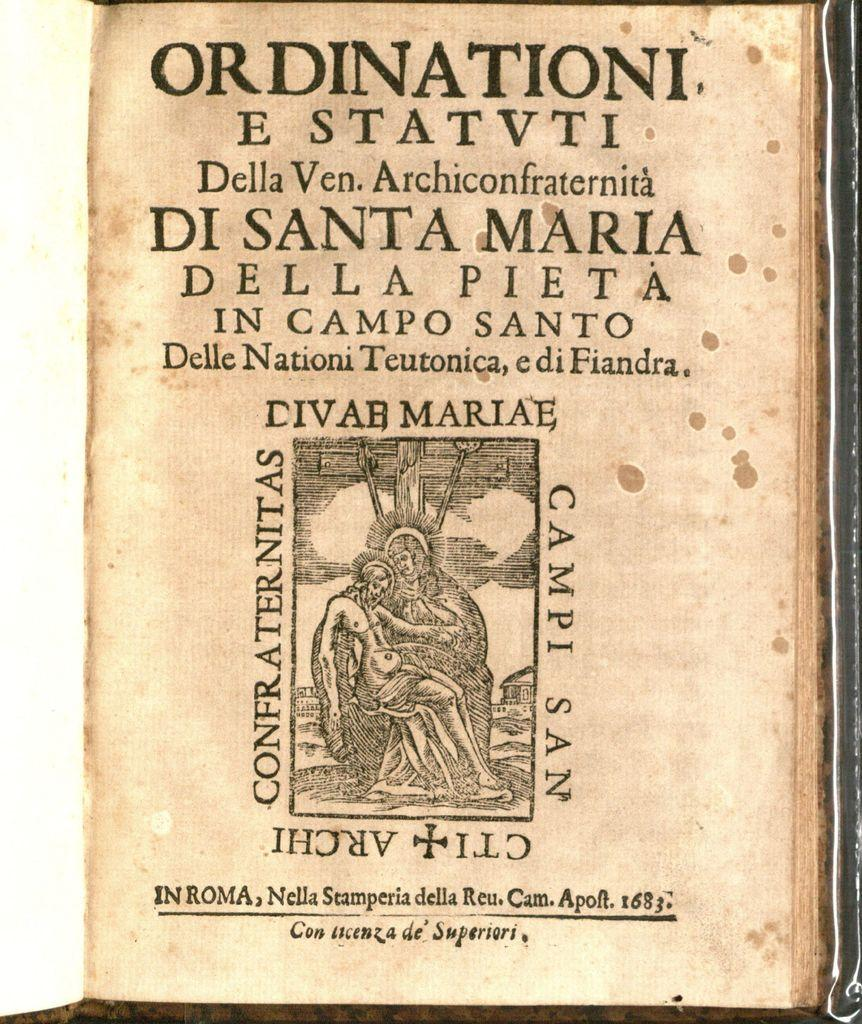<image>
Render a clear and concise summary of the photo. A very old book printed in Latin called Ordinationi E Statvti. 